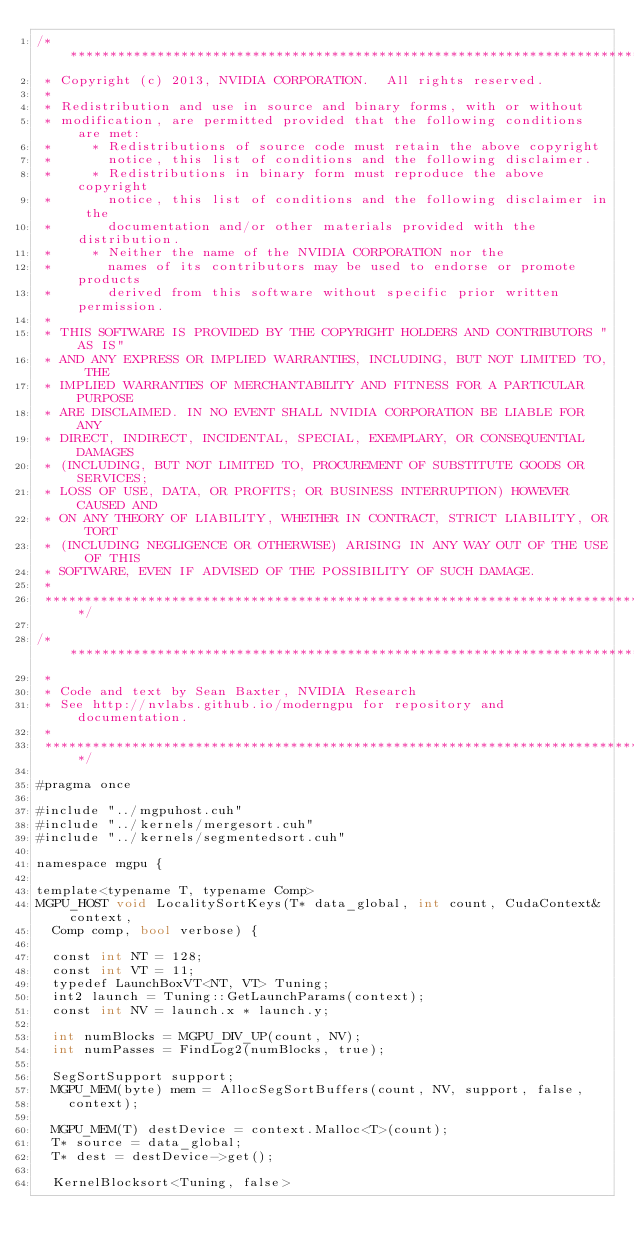<code> <loc_0><loc_0><loc_500><loc_500><_Cuda_>/******************************************************************************
 * Copyright (c) 2013, NVIDIA CORPORATION.  All rights reserved.
 *
 * Redistribution and use in source and binary forms, with or without
 * modification, are permitted provided that the following conditions are met:
 *     * Redistributions of source code must retain the above copyright
 *       notice, this list of conditions and the following disclaimer.
 *     * Redistributions in binary form must reproduce the above copyright
 *       notice, this list of conditions and the following disclaimer in the
 *       documentation and/or other materials provided with the distribution.
 *     * Neither the name of the NVIDIA CORPORATION nor the
 *       names of its contributors may be used to endorse or promote products
 *       derived from this software without specific prior written permission.
 *
 * THIS SOFTWARE IS PROVIDED BY THE COPYRIGHT HOLDERS AND CONTRIBUTORS "AS IS"
 * AND ANY EXPRESS OR IMPLIED WARRANTIES, INCLUDING, BUT NOT LIMITED TO, THE
 * IMPLIED WARRANTIES OF MERCHANTABILITY AND FITNESS FOR A PARTICULAR PURPOSE
 * ARE DISCLAIMED. IN NO EVENT SHALL NVIDIA CORPORATION BE LIABLE FOR ANY
 * DIRECT, INDIRECT, INCIDENTAL, SPECIAL, EXEMPLARY, OR CONSEQUENTIAL DAMAGES
 * (INCLUDING, BUT NOT LIMITED TO, PROCUREMENT OF SUBSTITUTE GOODS OR SERVICES;
 * LOSS OF USE, DATA, OR PROFITS; OR BUSINESS INTERRUPTION) HOWEVER CAUSED AND
 * ON ANY THEORY OF LIABILITY, WHETHER IN CONTRACT, STRICT LIABILITY, OR TORT
 * (INCLUDING NEGLIGENCE OR OTHERWISE) ARISING IN ANY WAY OUT OF THE USE OF THIS
 * SOFTWARE, EVEN IF ADVISED OF THE POSSIBILITY OF SUCH DAMAGE.
 *
 ******************************************************************************/

/******************************************************************************
 *
 * Code and text by Sean Baxter, NVIDIA Research
 * See http://nvlabs.github.io/moderngpu for repository and documentation.
 *
 ******************************************************************************/

#pragma once

#include "../mgpuhost.cuh"
#include "../kernels/mergesort.cuh"
#include "../kernels/segmentedsort.cuh"

namespace mgpu {

template<typename T, typename Comp>
MGPU_HOST void LocalitySortKeys(T* data_global, int count, CudaContext& context,
	Comp comp, bool verbose) {

	const int NT = 128;
	const int VT = 11;
	typedef LaunchBoxVT<NT, VT> Tuning;
	int2 launch = Tuning::GetLaunchParams(context);
	const int NV = launch.x * launch.y;

	int numBlocks = MGPU_DIV_UP(count, NV);
	int numPasses = FindLog2(numBlocks, true);

	SegSortSupport support;
	MGPU_MEM(byte) mem = AllocSegSortBuffers(count, NV, support, false,
		context);

	MGPU_MEM(T) destDevice = context.Malloc<T>(count);
	T* source = data_global;
	T* dest = destDevice->get();

	KernelBlocksort<Tuning, false></code> 